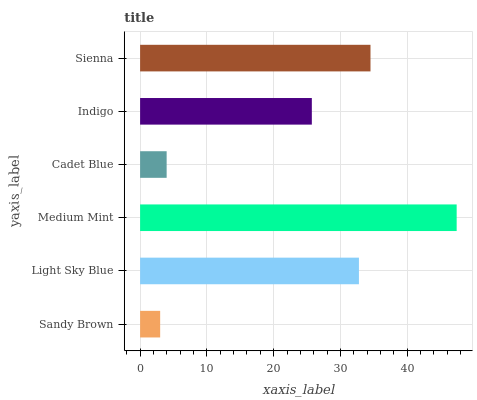Is Sandy Brown the minimum?
Answer yes or no. Yes. Is Medium Mint the maximum?
Answer yes or no. Yes. Is Light Sky Blue the minimum?
Answer yes or no. No. Is Light Sky Blue the maximum?
Answer yes or no. No. Is Light Sky Blue greater than Sandy Brown?
Answer yes or no. Yes. Is Sandy Brown less than Light Sky Blue?
Answer yes or no. Yes. Is Sandy Brown greater than Light Sky Blue?
Answer yes or no. No. Is Light Sky Blue less than Sandy Brown?
Answer yes or no. No. Is Light Sky Blue the high median?
Answer yes or no. Yes. Is Indigo the low median?
Answer yes or no. Yes. Is Medium Mint the high median?
Answer yes or no. No. Is Sienna the low median?
Answer yes or no. No. 